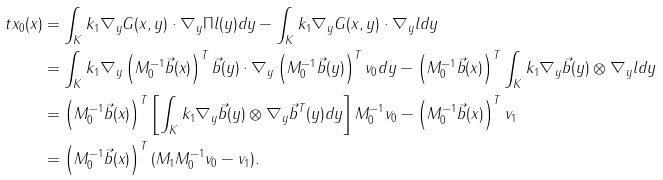Convert formula to latex. <formula><loc_0><loc_0><loc_500><loc_500>\ t x _ { 0 } ( x ) & = \int _ { K } k _ { 1 } \nabla _ { y } G ( x , y ) \cdot \nabla _ { y } \Pi l ( y ) d y - \int _ { K } k _ { 1 } \nabla _ { y } G ( x , y ) \cdot \nabla _ { y } l d y \\ & = \int _ { K } k _ { 1 } \nabla _ { y } \left ( M _ { 0 } ^ { - 1 } \vec { b } ( x ) \right ) ^ { T } \vec { b } ( y ) \cdot \nabla _ { y } \left ( M _ { 0 } ^ { - 1 } \vec { b } ( y ) \right ) ^ { T } v _ { 0 } d y - \left ( M _ { 0 } ^ { - 1 } \vec { b } ( x ) \right ) ^ { T } \int _ { K } k _ { 1 } \nabla _ { y } \vec { b } ( y ) \otimes \nabla _ { y } l d y \\ & = \left ( M _ { 0 } ^ { - 1 } \vec { b } ( x ) \right ) ^ { T } \left [ \int _ { K } k _ { 1 } \nabla _ { y } \vec { b } ( y ) \otimes \nabla _ { y } \vec { b } ^ { T } ( y ) d y \right ] M _ { 0 } ^ { - 1 } v _ { 0 } - \left ( M _ { 0 } ^ { - 1 } \vec { b } ( x ) \right ) ^ { T } v _ { 1 } \\ & = \left ( M _ { 0 } ^ { - 1 } \vec { b } ( x ) \right ) ^ { T } ( M _ { 1 } M _ { 0 } ^ { - 1 } v _ { 0 } - v _ { 1 } ) .</formula> 